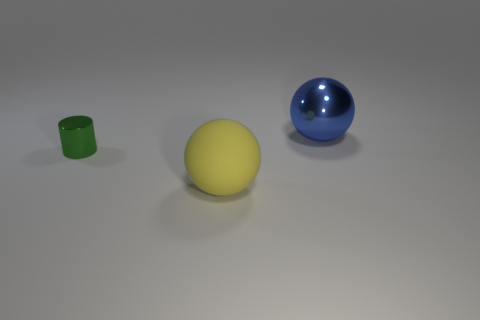Is the number of big blue things greater than the number of red cubes?
Offer a terse response. Yes. There is a metallic thing that is on the left side of the matte ball; what is its color?
Your answer should be compact. Green. Is the green metal thing the same shape as the yellow object?
Your answer should be very brief. No. There is a thing that is to the left of the large blue shiny sphere and behind the large rubber sphere; what color is it?
Your answer should be compact. Green. Does the ball behind the green metallic cylinder have the same size as the thing in front of the cylinder?
Your answer should be compact. Yes. How many things are either balls that are left of the big shiny thing or small metallic cylinders?
Provide a succinct answer. 2. What is the big blue sphere made of?
Make the answer very short. Metal. Do the yellow thing and the green cylinder have the same size?
Offer a terse response. No. How many cylinders are either shiny things or green shiny things?
Your answer should be very brief. 1. The large thing behind the metallic object that is in front of the blue metallic ball is what color?
Make the answer very short. Blue. 